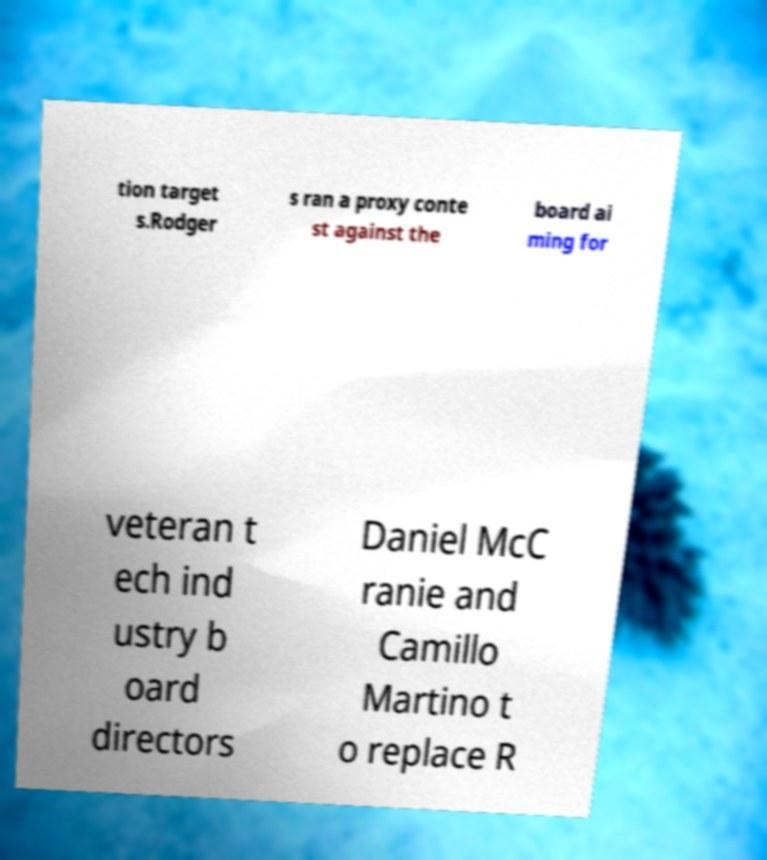There's text embedded in this image that I need extracted. Can you transcribe it verbatim? tion target s.Rodger s ran a proxy conte st against the board ai ming for veteran t ech ind ustry b oard directors Daniel McC ranie and Camillo Martino t o replace R 